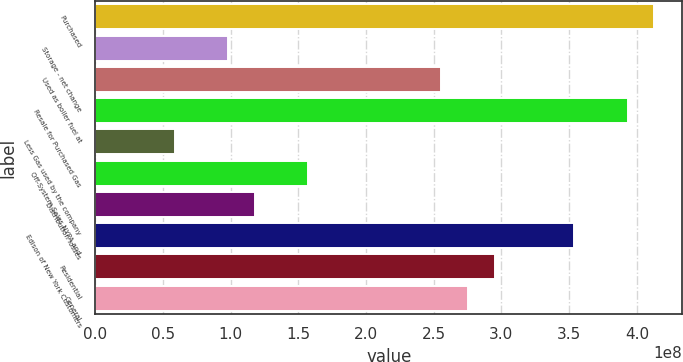<chart> <loc_0><loc_0><loc_500><loc_500><bar_chart><fcel>Purchased<fcel>Storage - net change<fcel>Used as boiler fuel at<fcel>Resale for Purchased Gas<fcel>Less Gas used by the company<fcel>Off-System Sales NYPA and<fcel>Distribution losses<fcel>Edison of New York Customers<fcel>Residential<fcel>General<nl><fcel>4.12933e+08<fcel>9.83174e+07<fcel>2.55625e+08<fcel>3.93269e+08<fcel>5.89904e+07<fcel>1.57308e+08<fcel>1.17981e+08<fcel>3.53943e+08<fcel>2.94952e+08<fcel>2.75289e+08<nl></chart> 